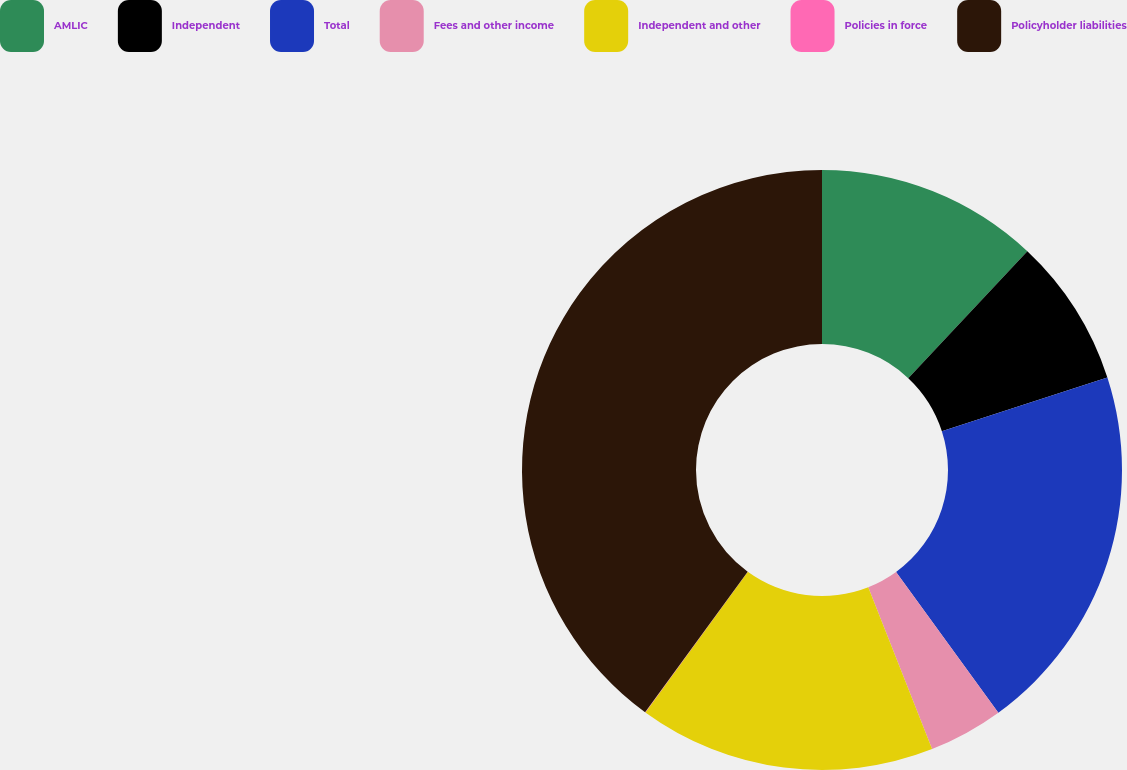Convert chart to OTSL. <chart><loc_0><loc_0><loc_500><loc_500><pie_chart><fcel>AMLIC<fcel>Independent<fcel>Total<fcel>Fees and other income<fcel>Independent and other<fcel>Policies in force<fcel>Policyholder liabilities<nl><fcel>12.0%<fcel>8.01%<fcel>19.99%<fcel>4.02%<fcel>16.0%<fcel>0.02%<fcel>39.96%<nl></chart> 